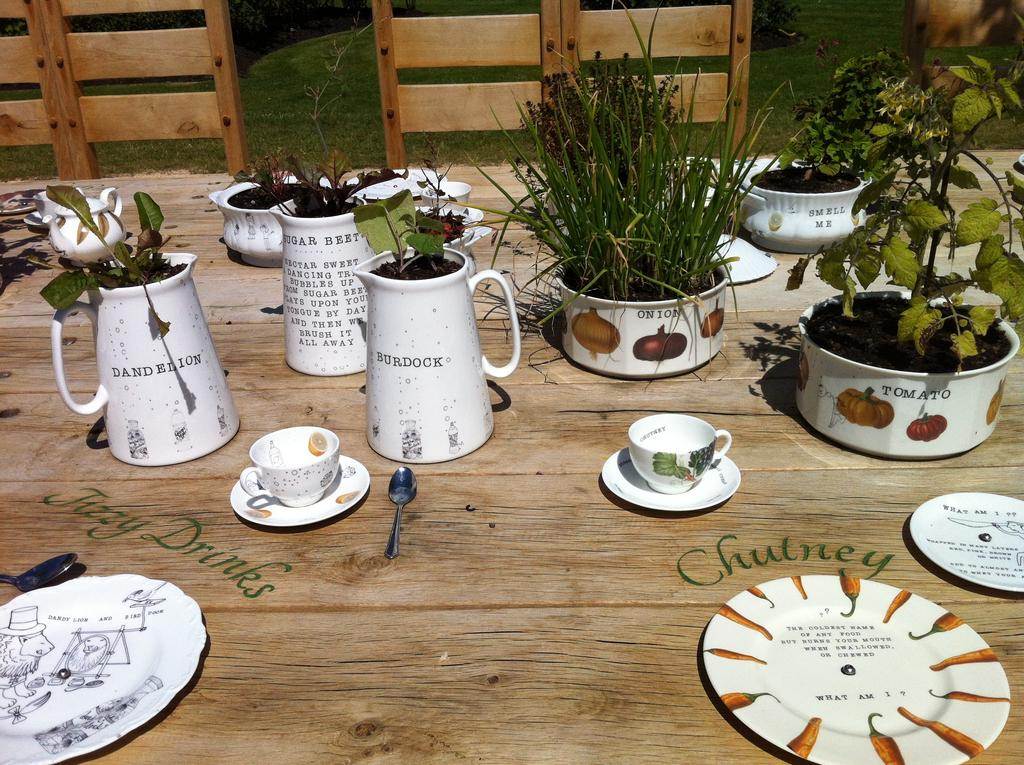What type of container is present in the image? There is a jug in the image. What other object is present that can be used for holding liquids? There is a cup in the image. What is used for placing the cup on the table? There is a saucer in the image. What utensil is present in the image? There is a spoon in the image. What type of living organism is in the image? There is a plant in the image. What part of the plant is visible in the image? There are leaves in the image. What substance is present in the image? There is mud in the image. On what surface are the objects placed? The objects are placed on a wooden table. What type of furniture is visible in the background of the image? There are wooden chairs in the background of the image. What type of natural environment is visible in the background of the image? There is grass visible in the background of the image. Where are the bells located in the image? There are no bells present in the image. What type of animal is the toad interacting with the plant in the image? There is no toad present in the image. 